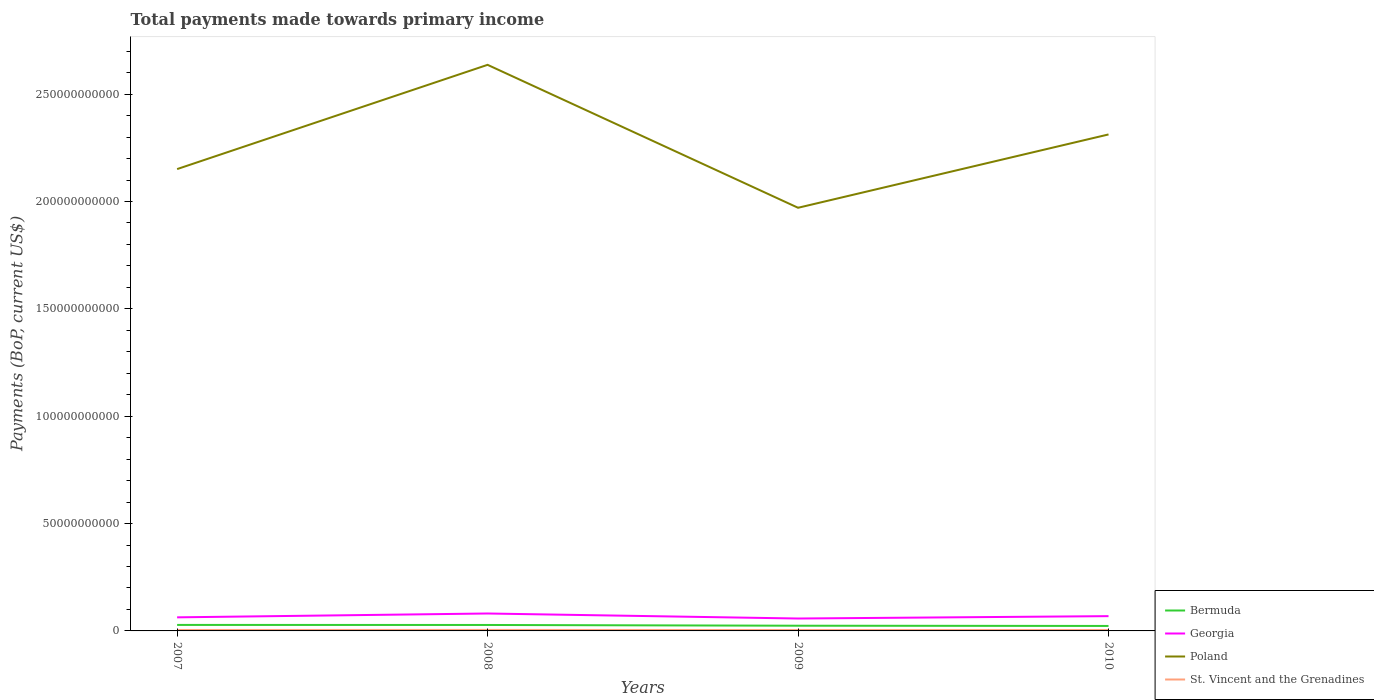How many different coloured lines are there?
Provide a short and direct response. 4. Is the number of lines equal to the number of legend labels?
Your answer should be very brief. Yes. Across all years, what is the maximum total payments made towards primary income in Poland?
Ensure brevity in your answer.  1.97e+11. What is the total total payments made towards primary income in St. Vincent and the Grenadines in the graph?
Make the answer very short. 6.12e+05. What is the difference between the highest and the second highest total payments made towards primary income in Poland?
Provide a succinct answer. 6.66e+1. What is the difference between two consecutive major ticks on the Y-axis?
Keep it short and to the point. 5.00e+1. Are the values on the major ticks of Y-axis written in scientific E-notation?
Your answer should be very brief. No. Does the graph contain grids?
Provide a short and direct response. No. Where does the legend appear in the graph?
Your answer should be very brief. Bottom right. How many legend labels are there?
Your response must be concise. 4. What is the title of the graph?
Keep it short and to the point. Total payments made towards primary income. What is the label or title of the Y-axis?
Make the answer very short. Payments (BoP, current US$). What is the Payments (BoP, current US$) in Bermuda in 2007?
Your answer should be compact. 2.79e+09. What is the Payments (BoP, current US$) of Georgia in 2007?
Ensure brevity in your answer.  6.32e+09. What is the Payments (BoP, current US$) in Poland in 2007?
Your answer should be compact. 2.15e+11. What is the Payments (BoP, current US$) in St. Vincent and the Grenadines in 2007?
Your answer should be very brief. 4.38e+08. What is the Payments (BoP, current US$) in Bermuda in 2008?
Your answer should be very brief. 2.77e+09. What is the Payments (BoP, current US$) in Georgia in 2008?
Provide a short and direct response. 8.11e+09. What is the Payments (BoP, current US$) in Poland in 2008?
Offer a very short reply. 2.64e+11. What is the Payments (BoP, current US$) of St. Vincent and the Grenadines in 2008?
Offer a terse response. 4.64e+08. What is the Payments (BoP, current US$) of Bermuda in 2009?
Offer a terse response. 2.42e+09. What is the Payments (BoP, current US$) in Georgia in 2009?
Your response must be concise. 5.78e+09. What is the Payments (BoP, current US$) in Poland in 2009?
Provide a succinct answer. 1.97e+11. What is the Payments (BoP, current US$) of St. Vincent and the Grenadines in 2009?
Ensure brevity in your answer.  4.15e+08. What is the Payments (BoP, current US$) in Bermuda in 2010?
Your answer should be very brief. 2.32e+09. What is the Payments (BoP, current US$) in Georgia in 2010?
Your response must be concise. 6.89e+09. What is the Payments (BoP, current US$) in Poland in 2010?
Your answer should be compact. 2.31e+11. What is the Payments (BoP, current US$) of St. Vincent and the Grenadines in 2010?
Offer a very short reply. 4.14e+08. Across all years, what is the maximum Payments (BoP, current US$) of Bermuda?
Keep it short and to the point. 2.79e+09. Across all years, what is the maximum Payments (BoP, current US$) in Georgia?
Your answer should be compact. 8.11e+09. Across all years, what is the maximum Payments (BoP, current US$) in Poland?
Your response must be concise. 2.64e+11. Across all years, what is the maximum Payments (BoP, current US$) of St. Vincent and the Grenadines?
Give a very brief answer. 4.64e+08. Across all years, what is the minimum Payments (BoP, current US$) in Bermuda?
Offer a very short reply. 2.32e+09. Across all years, what is the minimum Payments (BoP, current US$) in Georgia?
Give a very brief answer. 5.78e+09. Across all years, what is the minimum Payments (BoP, current US$) in Poland?
Ensure brevity in your answer.  1.97e+11. Across all years, what is the minimum Payments (BoP, current US$) of St. Vincent and the Grenadines?
Offer a terse response. 4.14e+08. What is the total Payments (BoP, current US$) of Bermuda in the graph?
Provide a succinct answer. 1.03e+1. What is the total Payments (BoP, current US$) of Georgia in the graph?
Your answer should be compact. 2.71e+1. What is the total Payments (BoP, current US$) of Poland in the graph?
Make the answer very short. 9.07e+11. What is the total Payments (BoP, current US$) of St. Vincent and the Grenadines in the graph?
Your response must be concise. 1.73e+09. What is the difference between the Payments (BoP, current US$) in Bermuda in 2007 and that in 2008?
Your response must be concise. 1.81e+07. What is the difference between the Payments (BoP, current US$) of Georgia in 2007 and that in 2008?
Keep it short and to the point. -1.79e+09. What is the difference between the Payments (BoP, current US$) in Poland in 2007 and that in 2008?
Provide a succinct answer. -4.86e+1. What is the difference between the Payments (BoP, current US$) in St. Vincent and the Grenadines in 2007 and that in 2008?
Make the answer very short. -2.62e+07. What is the difference between the Payments (BoP, current US$) in Bermuda in 2007 and that in 2009?
Ensure brevity in your answer.  3.73e+08. What is the difference between the Payments (BoP, current US$) in Georgia in 2007 and that in 2009?
Offer a terse response. 5.46e+08. What is the difference between the Payments (BoP, current US$) of Poland in 2007 and that in 2009?
Make the answer very short. 1.80e+1. What is the difference between the Payments (BoP, current US$) of St. Vincent and the Grenadines in 2007 and that in 2009?
Your answer should be very brief. 2.28e+07. What is the difference between the Payments (BoP, current US$) in Bermuda in 2007 and that in 2010?
Offer a terse response. 4.75e+08. What is the difference between the Payments (BoP, current US$) of Georgia in 2007 and that in 2010?
Ensure brevity in your answer.  -5.60e+08. What is the difference between the Payments (BoP, current US$) in Poland in 2007 and that in 2010?
Your answer should be compact. -1.61e+1. What is the difference between the Payments (BoP, current US$) in St. Vincent and the Grenadines in 2007 and that in 2010?
Make the answer very short. 2.34e+07. What is the difference between the Payments (BoP, current US$) of Bermuda in 2008 and that in 2009?
Give a very brief answer. 3.54e+08. What is the difference between the Payments (BoP, current US$) in Georgia in 2008 and that in 2009?
Your answer should be very brief. 2.34e+09. What is the difference between the Payments (BoP, current US$) in Poland in 2008 and that in 2009?
Keep it short and to the point. 6.66e+1. What is the difference between the Payments (BoP, current US$) of St. Vincent and the Grenadines in 2008 and that in 2009?
Provide a short and direct response. 4.90e+07. What is the difference between the Payments (BoP, current US$) of Bermuda in 2008 and that in 2010?
Your answer should be very brief. 4.57e+08. What is the difference between the Payments (BoP, current US$) of Georgia in 2008 and that in 2010?
Offer a very short reply. 1.23e+09. What is the difference between the Payments (BoP, current US$) of Poland in 2008 and that in 2010?
Make the answer very short. 3.24e+1. What is the difference between the Payments (BoP, current US$) of St. Vincent and the Grenadines in 2008 and that in 2010?
Provide a short and direct response. 4.96e+07. What is the difference between the Payments (BoP, current US$) of Bermuda in 2009 and that in 2010?
Keep it short and to the point. 1.03e+08. What is the difference between the Payments (BoP, current US$) of Georgia in 2009 and that in 2010?
Keep it short and to the point. -1.11e+09. What is the difference between the Payments (BoP, current US$) in Poland in 2009 and that in 2010?
Provide a succinct answer. -3.42e+1. What is the difference between the Payments (BoP, current US$) of St. Vincent and the Grenadines in 2009 and that in 2010?
Keep it short and to the point. 6.12e+05. What is the difference between the Payments (BoP, current US$) in Bermuda in 2007 and the Payments (BoP, current US$) in Georgia in 2008?
Offer a terse response. -5.32e+09. What is the difference between the Payments (BoP, current US$) of Bermuda in 2007 and the Payments (BoP, current US$) of Poland in 2008?
Offer a very short reply. -2.61e+11. What is the difference between the Payments (BoP, current US$) in Bermuda in 2007 and the Payments (BoP, current US$) in St. Vincent and the Grenadines in 2008?
Ensure brevity in your answer.  2.33e+09. What is the difference between the Payments (BoP, current US$) of Georgia in 2007 and the Payments (BoP, current US$) of Poland in 2008?
Offer a very short reply. -2.57e+11. What is the difference between the Payments (BoP, current US$) of Georgia in 2007 and the Payments (BoP, current US$) of St. Vincent and the Grenadines in 2008?
Offer a terse response. 5.86e+09. What is the difference between the Payments (BoP, current US$) in Poland in 2007 and the Payments (BoP, current US$) in St. Vincent and the Grenadines in 2008?
Your answer should be very brief. 2.15e+11. What is the difference between the Payments (BoP, current US$) in Bermuda in 2007 and the Payments (BoP, current US$) in Georgia in 2009?
Offer a very short reply. -2.99e+09. What is the difference between the Payments (BoP, current US$) in Bermuda in 2007 and the Payments (BoP, current US$) in Poland in 2009?
Provide a succinct answer. -1.94e+11. What is the difference between the Payments (BoP, current US$) in Bermuda in 2007 and the Payments (BoP, current US$) in St. Vincent and the Grenadines in 2009?
Your answer should be very brief. 2.38e+09. What is the difference between the Payments (BoP, current US$) of Georgia in 2007 and the Payments (BoP, current US$) of Poland in 2009?
Your response must be concise. -1.91e+11. What is the difference between the Payments (BoP, current US$) of Georgia in 2007 and the Payments (BoP, current US$) of St. Vincent and the Grenadines in 2009?
Offer a terse response. 5.91e+09. What is the difference between the Payments (BoP, current US$) of Poland in 2007 and the Payments (BoP, current US$) of St. Vincent and the Grenadines in 2009?
Give a very brief answer. 2.15e+11. What is the difference between the Payments (BoP, current US$) in Bermuda in 2007 and the Payments (BoP, current US$) in Georgia in 2010?
Provide a short and direct response. -4.09e+09. What is the difference between the Payments (BoP, current US$) of Bermuda in 2007 and the Payments (BoP, current US$) of Poland in 2010?
Make the answer very short. -2.28e+11. What is the difference between the Payments (BoP, current US$) of Bermuda in 2007 and the Payments (BoP, current US$) of St. Vincent and the Grenadines in 2010?
Offer a very short reply. 2.38e+09. What is the difference between the Payments (BoP, current US$) of Georgia in 2007 and the Payments (BoP, current US$) of Poland in 2010?
Give a very brief answer. -2.25e+11. What is the difference between the Payments (BoP, current US$) of Georgia in 2007 and the Payments (BoP, current US$) of St. Vincent and the Grenadines in 2010?
Ensure brevity in your answer.  5.91e+09. What is the difference between the Payments (BoP, current US$) in Poland in 2007 and the Payments (BoP, current US$) in St. Vincent and the Grenadines in 2010?
Your answer should be compact. 2.15e+11. What is the difference between the Payments (BoP, current US$) of Bermuda in 2008 and the Payments (BoP, current US$) of Georgia in 2009?
Provide a short and direct response. -3.01e+09. What is the difference between the Payments (BoP, current US$) of Bermuda in 2008 and the Payments (BoP, current US$) of Poland in 2009?
Your answer should be compact. -1.94e+11. What is the difference between the Payments (BoP, current US$) in Bermuda in 2008 and the Payments (BoP, current US$) in St. Vincent and the Grenadines in 2009?
Provide a short and direct response. 2.36e+09. What is the difference between the Payments (BoP, current US$) in Georgia in 2008 and the Payments (BoP, current US$) in Poland in 2009?
Provide a succinct answer. -1.89e+11. What is the difference between the Payments (BoP, current US$) of Georgia in 2008 and the Payments (BoP, current US$) of St. Vincent and the Grenadines in 2009?
Ensure brevity in your answer.  7.70e+09. What is the difference between the Payments (BoP, current US$) of Poland in 2008 and the Payments (BoP, current US$) of St. Vincent and the Grenadines in 2009?
Offer a terse response. 2.63e+11. What is the difference between the Payments (BoP, current US$) in Bermuda in 2008 and the Payments (BoP, current US$) in Georgia in 2010?
Ensure brevity in your answer.  -4.11e+09. What is the difference between the Payments (BoP, current US$) in Bermuda in 2008 and the Payments (BoP, current US$) in Poland in 2010?
Keep it short and to the point. -2.28e+11. What is the difference between the Payments (BoP, current US$) of Bermuda in 2008 and the Payments (BoP, current US$) of St. Vincent and the Grenadines in 2010?
Keep it short and to the point. 2.36e+09. What is the difference between the Payments (BoP, current US$) of Georgia in 2008 and the Payments (BoP, current US$) of Poland in 2010?
Offer a terse response. -2.23e+11. What is the difference between the Payments (BoP, current US$) of Georgia in 2008 and the Payments (BoP, current US$) of St. Vincent and the Grenadines in 2010?
Keep it short and to the point. 7.70e+09. What is the difference between the Payments (BoP, current US$) in Poland in 2008 and the Payments (BoP, current US$) in St. Vincent and the Grenadines in 2010?
Provide a short and direct response. 2.63e+11. What is the difference between the Payments (BoP, current US$) in Bermuda in 2009 and the Payments (BoP, current US$) in Georgia in 2010?
Give a very brief answer. -4.47e+09. What is the difference between the Payments (BoP, current US$) in Bermuda in 2009 and the Payments (BoP, current US$) in Poland in 2010?
Offer a terse response. -2.29e+11. What is the difference between the Payments (BoP, current US$) of Bermuda in 2009 and the Payments (BoP, current US$) of St. Vincent and the Grenadines in 2010?
Keep it short and to the point. 2.01e+09. What is the difference between the Payments (BoP, current US$) of Georgia in 2009 and the Payments (BoP, current US$) of Poland in 2010?
Offer a very short reply. -2.25e+11. What is the difference between the Payments (BoP, current US$) in Georgia in 2009 and the Payments (BoP, current US$) in St. Vincent and the Grenadines in 2010?
Provide a succinct answer. 5.36e+09. What is the difference between the Payments (BoP, current US$) of Poland in 2009 and the Payments (BoP, current US$) of St. Vincent and the Grenadines in 2010?
Provide a succinct answer. 1.97e+11. What is the average Payments (BoP, current US$) in Bermuda per year?
Offer a very short reply. 2.58e+09. What is the average Payments (BoP, current US$) of Georgia per year?
Ensure brevity in your answer.  6.78e+09. What is the average Payments (BoP, current US$) in Poland per year?
Give a very brief answer. 2.27e+11. What is the average Payments (BoP, current US$) of St. Vincent and the Grenadines per year?
Your response must be concise. 4.33e+08. In the year 2007, what is the difference between the Payments (BoP, current US$) in Bermuda and Payments (BoP, current US$) in Georgia?
Provide a succinct answer. -3.53e+09. In the year 2007, what is the difference between the Payments (BoP, current US$) in Bermuda and Payments (BoP, current US$) in Poland?
Make the answer very short. -2.12e+11. In the year 2007, what is the difference between the Payments (BoP, current US$) in Bermuda and Payments (BoP, current US$) in St. Vincent and the Grenadines?
Offer a terse response. 2.35e+09. In the year 2007, what is the difference between the Payments (BoP, current US$) of Georgia and Payments (BoP, current US$) of Poland?
Provide a short and direct response. -2.09e+11. In the year 2007, what is the difference between the Payments (BoP, current US$) in Georgia and Payments (BoP, current US$) in St. Vincent and the Grenadines?
Your response must be concise. 5.89e+09. In the year 2007, what is the difference between the Payments (BoP, current US$) in Poland and Payments (BoP, current US$) in St. Vincent and the Grenadines?
Your answer should be compact. 2.15e+11. In the year 2008, what is the difference between the Payments (BoP, current US$) in Bermuda and Payments (BoP, current US$) in Georgia?
Offer a very short reply. -5.34e+09. In the year 2008, what is the difference between the Payments (BoP, current US$) in Bermuda and Payments (BoP, current US$) in Poland?
Provide a short and direct response. -2.61e+11. In the year 2008, what is the difference between the Payments (BoP, current US$) of Bermuda and Payments (BoP, current US$) of St. Vincent and the Grenadines?
Ensure brevity in your answer.  2.31e+09. In the year 2008, what is the difference between the Payments (BoP, current US$) in Georgia and Payments (BoP, current US$) in Poland?
Give a very brief answer. -2.56e+11. In the year 2008, what is the difference between the Payments (BoP, current US$) in Georgia and Payments (BoP, current US$) in St. Vincent and the Grenadines?
Make the answer very short. 7.65e+09. In the year 2008, what is the difference between the Payments (BoP, current US$) of Poland and Payments (BoP, current US$) of St. Vincent and the Grenadines?
Your answer should be compact. 2.63e+11. In the year 2009, what is the difference between the Payments (BoP, current US$) of Bermuda and Payments (BoP, current US$) of Georgia?
Your answer should be compact. -3.36e+09. In the year 2009, what is the difference between the Payments (BoP, current US$) of Bermuda and Payments (BoP, current US$) of Poland?
Give a very brief answer. -1.95e+11. In the year 2009, what is the difference between the Payments (BoP, current US$) of Bermuda and Payments (BoP, current US$) of St. Vincent and the Grenadines?
Your response must be concise. 2.00e+09. In the year 2009, what is the difference between the Payments (BoP, current US$) in Georgia and Payments (BoP, current US$) in Poland?
Your answer should be very brief. -1.91e+11. In the year 2009, what is the difference between the Payments (BoP, current US$) in Georgia and Payments (BoP, current US$) in St. Vincent and the Grenadines?
Keep it short and to the point. 5.36e+09. In the year 2009, what is the difference between the Payments (BoP, current US$) in Poland and Payments (BoP, current US$) in St. Vincent and the Grenadines?
Your answer should be compact. 1.97e+11. In the year 2010, what is the difference between the Payments (BoP, current US$) of Bermuda and Payments (BoP, current US$) of Georgia?
Your response must be concise. -4.57e+09. In the year 2010, what is the difference between the Payments (BoP, current US$) in Bermuda and Payments (BoP, current US$) in Poland?
Provide a short and direct response. -2.29e+11. In the year 2010, what is the difference between the Payments (BoP, current US$) in Bermuda and Payments (BoP, current US$) in St. Vincent and the Grenadines?
Make the answer very short. 1.90e+09. In the year 2010, what is the difference between the Payments (BoP, current US$) in Georgia and Payments (BoP, current US$) in Poland?
Your answer should be very brief. -2.24e+11. In the year 2010, what is the difference between the Payments (BoP, current US$) of Georgia and Payments (BoP, current US$) of St. Vincent and the Grenadines?
Your answer should be very brief. 6.47e+09. In the year 2010, what is the difference between the Payments (BoP, current US$) in Poland and Payments (BoP, current US$) in St. Vincent and the Grenadines?
Make the answer very short. 2.31e+11. What is the ratio of the Payments (BoP, current US$) in Georgia in 2007 to that in 2008?
Offer a very short reply. 0.78. What is the ratio of the Payments (BoP, current US$) in Poland in 2007 to that in 2008?
Give a very brief answer. 0.82. What is the ratio of the Payments (BoP, current US$) in St. Vincent and the Grenadines in 2007 to that in 2008?
Keep it short and to the point. 0.94. What is the ratio of the Payments (BoP, current US$) of Bermuda in 2007 to that in 2009?
Your answer should be very brief. 1.15. What is the ratio of the Payments (BoP, current US$) of Georgia in 2007 to that in 2009?
Offer a very short reply. 1.09. What is the ratio of the Payments (BoP, current US$) in Poland in 2007 to that in 2009?
Ensure brevity in your answer.  1.09. What is the ratio of the Payments (BoP, current US$) of St. Vincent and the Grenadines in 2007 to that in 2009?
Provide a succinct answer. 1.05. What is the ratio of the Payments (BoP, current US$) in Bermuda in 2007 to that in 2010?
Give a very brief answer. 1.21. What is the ratio of the Payments (BoP, current US$) of Georgia in 2007 to that in 2010?
Make the answer very short. 0.92. What is the ratio of the Payments (BoP, current US$) of Poland in 2007 to that in 2010?
Make the answer very short. 0.93. What is the ratio of the Payments (BoP, current US$) of St. Vincent and the Grenadines in 2007 to that in 2010?
Offer a very short reply. 1.06. What is the ratio of the Payments (BoP, current US$) in Bermuda in 2008 to that in 2009?
Make the answer very short. 1.15. What is the ratio of the Payments (BoP, current US$) in Georgia in 2008 to that in 2009?
Give a very brief answer. 1.4. What is the ratio of the Payments (BoP, current US$) in Poland in 2008 to that in 2009?
Provide a succinct answer. 1.34. What is the ratio of the Payments (BoP, current US$) of St. Vincent and the Grenadines in 2008 to that in 2009?
Your answer should be compact. 1.12. What is the ratio of the Payments (BoP, current US$) of Bermuda in 2008 to that in 2010?
Keep it short and to the point. 1.2. What is the ratio of the Payments (BoP, current US$) of Georgia in 2008 to that in 2010?
Provide a short and direct response. 1.18. What is the ratio of the Payments (BoP, current US$) in Poland in 2008 to that in 2010?
Your answer should be compact. 1.14. What is the ratio of the Payments (BoP, current US$) of St. Vincent and the Grenadines in 2008 to that in 2010?
Provide a succinct answer. 1.12. What is the ratio of the Payments (BoP, current US$) in Bermuda in 2009 to that in 2010?
Make the answer very short. 1.04. What is the ratio of the Payments (BoP, current US$) of Georgia in 2009 to that in 2010?
Offer a terse response. 0.84. What is the ratio of the Payments (BoP, current US$) of Poland in 2009 to that in 2010?
Your answer should be compact. 0.85. What is the difference between the highest and the second highest Payments (BoP, current US$) in Bermuda?
Ensure brevity in your answer.  1.81e+07. What is the difference between the highest and the second highest Payments (BoP, current US$) in Georgia?
Make the answer very short. 1.23e+09. What is the difference between the highest and the second highest Payments (BoP, current US$) in Poland?
Provide a short and direct response. 3.24e+1. What is the difference between the highest and the second highest Payments (BoP, current US$) in St. Vincent and the Grenadines?
Your answer should be compact. 2.62e+07. What is the difference between the highest and the lowest Payments (BoP, current US$) in Bermuda?
Your response must be concise. 4.75e+08. What is the difference between the highest and the lowest Payments (BoP, current US$) of Georgia?
Make the answer very short. 2.34e+09. What is the difference between the highest and the lowest Payments (BoP, current US$) of Poland?
Keep it short and to the point. 6.66e+1. What is the difference between the highest and the lowest Payments (BoP, current US$) of St. Vincent and the Grenadines?
Provide a short and direct response. 4.96e+07. 